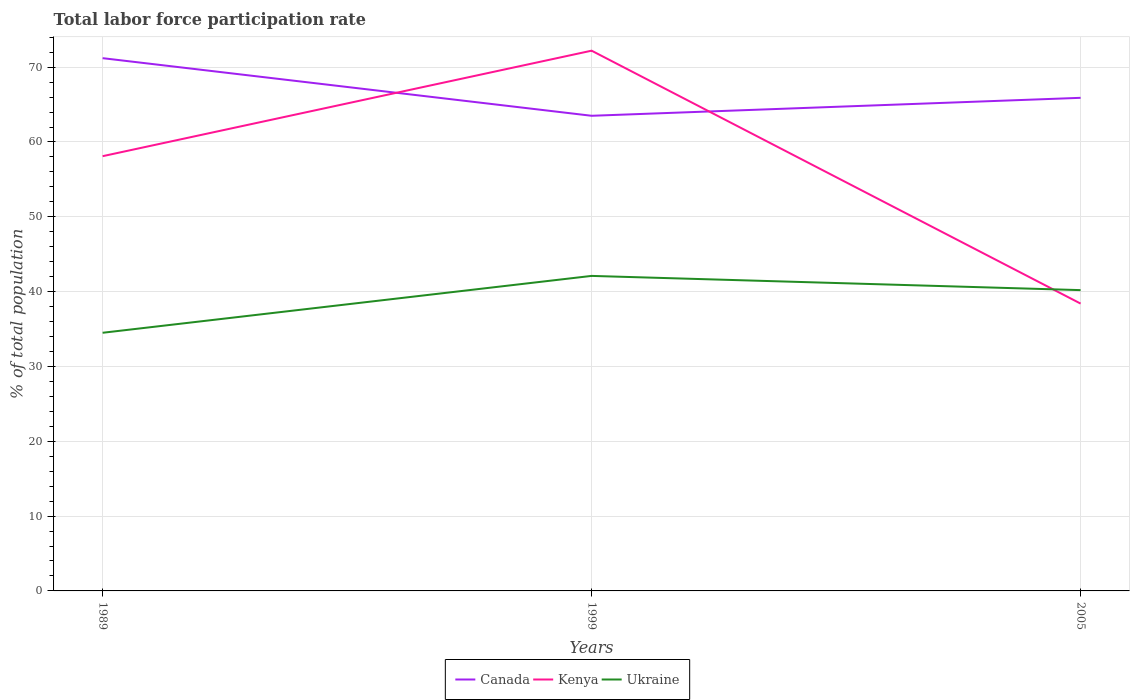How many different coloured lines are there?
Offer a very short reply. 3. Does the line corresponding to Ukraine intersect with the line corresponding to Canada?
Ensure brevity in your answer.  No. Is the number of lines equal to the number of legend labels?
Ensure brevity in your answer.  Yes. Across all years, what is the maximum total labor force participation rate in Kenya?
Offer a terse response. 38.4. What is the total total labor force participation rate in Kenya in the graph?
Provide a succinct answer. 19.7. What is the difference between the highest and the second highest total labor force participation rate in Kenya?
Your answer should be compact. 33.8. Is the total labor force participation rate in Kenya strictly greater than the total labor force participation rate in Canada over the years?
Make the answer very short. No. What is the difference between two consecutive major ticks on the Y-axis?
Ensure brevity in your answer.  10. How many legend labels are there?
Provide a succinct answer. 3. What is the title of the graph?
Provide a short and direct response. Total labor force participation rate. Does "Benin" appear as one of the legend labels in the graph?
Your answer should be compact. No. What is the label or title of the X-axis?
Make the answer very short. Years. What is the label or title of the Y-axis?
Provide a short and direct response. % of total population. What is the % of total population of Canada in 1989?
Provide a short and direct response. 71.2. What is the % of total population of Kenya in 1989?
Your response must be concise. 58.1. What is the % of total population in Ukraine in 1989?
Offer a terse response. 34.5. What is the % of total population of Canada in 1999?
Your answer should be compact. 63.5. What is the % of total population of Kenya in 1999?
Provide a succinct answer. 72.2. What is the % of total population in Ukraine in 1999?
Your answer should be compact. 42.1. What is the % of total population in Canada in 2005?
Your response must be concise. 65.9. What is the % of total population of Kenya in 2005?
Your answer should be very brief. 38.4. What is the % of total population in Ukraine in 2005?
Make the answer very short. 40.2. Across all years, what is the maximum % of total population of Canada?
Offer a terse response. 71.2. Across all years, what is the maximum % of total population in Kenya?
Provide a short and direct response. 72.2. Across all years, what is the maximum % of total population in Ukraine?
Provide a short and direct response. 42.1. Across all years, what is the minimum % of total population in Canada?
Ensure brevity in your answer.  63.5. Across all years, what is the minimum % of total population of Kenya?
Make the answer very short. 38.4. Across all years, what is the minimum % of total population in Ukraine?
Offer a very short reply. 34.5. What is the total % of total population in Canada in the graph?
Provide a short and direct response. 200.6. What is the total % of total population of Kenya in the graph?
Give a very brief answer. 168.7. What is the total % of total population in Ukraine in the graph?
Your response must be concise. 116.8. What is the difference between the % of total population in Kenya in 1989 and that in 1999?
Give a very brief answer. -14.1. What is the difference between the % of total population of Ukraine in 1989 and that in 1999?
Provide a succinct answer. -7.6. What is the difference between the % of total population in Kenya in 1999 and that in 2005?
Offer a terse response. 33.8. What is the difference between the % of total population in Ukraine in 1999 and that in 2005?
Keep it short and to the point. 1.9. What is the difference between the % of total population of Canada in 1989 and the % of total population of Kenya in 1999?
Give a very brief answer. -1. What is the difference between the % of total population in Canada in 1989 and the % of total population in Ukraine in 1999?
Keep it short and to the point. 29.1. What is the difference between the % of total population of Canada in 1989 and the % of total population of Kenya in 2005?
Provide a short and direct response. 32.8. What is the difference between the % of total population in Canada in 1989 and the % of total population in Ukraine in 2005?
Ensure brevity in your answer.  31. What is the difference between the % of total population of Kenya in 1989 and the % of total population of Ukraine in 2005?
Offer a terse response. 17.9. What is the difference between the % of total population of Canada in 1999 and the % of total population of Kenya in 2005?
Your answer should be very brief. 25.1. What is the difference between the % of total population in Canada in 1999 and the % of total population in Ukraine in 2005?
Provide a short and direct response. 23.3. What is the average % of total population of Canada per year?
Ensure brevity in your answer.  66.87. What is the average % of total population in Kenya per year?
Provide a short and direct response. 56.23. What is the average % of total population in Ukraine per year?
Ensure brevity in your answer.  38.93. In the year 1989, what is the difference between the % of total population in Canada and % of total population in Kenya?
Keep it short and to the point. 13.1. In the year 1989, what is the difference between the % of total population in Canada and % of total population in Ukraine?
Offer a terse response. 36.7. In the year 1989, what is the difference between the % of total population of Kenya and % of total population of Ukraine?
Give a very brief answer. 23.6. In the year 1999, what is the difference between the % of total population of Canada and % of total population of Ukraine?
Provide a succinct answer. 21.4. In the year 1999, what is the difference between the % of total population in Kenya and % of total population in Ukraine?
Offer a terse response. 30.1. In the year 2005, what is the difference between the % of total population in Canada and % of total population in Ukraine?
Provide a short and direct response. 25.7. In the year 2005, what is the difference between the % of total population of Kenya and % of total population of Ukraine?
Keep it short and to the point. -1.8. What is the ratio of the % of total population in Canada in 1989 to that in 1999?
Offer a very short reply. 1.12. What is the ratio of the % of total population of Kenya in 1989 to that in 1999?
Give a very brief answer. 0.8. What is the ratio of the % of total population in Ukraine in 1989 to that in 1999?
Provide a short and direct response. 0.82. What is the ratio of the % of total population in Canada in 1989 to that in 2005?
Your response must be concise. 1.08. What is the ratio of the % of total population in Kenya in 1989 to that in 2005?
Your response must be concise. 1.51. What is the ratio of the % of total population in Ukraine in 1989 to that in 2005?
Ensure brevity in your answer.  0.86. What is the ratio of the % of total population in Canada in 1999 to that in 2005?
Ensure brevity in your answer.  0.96. What is the ratio of the % of total population in Kenya in 1999 to that in 2005?
Provide a short and direct response. 1.88. What is the ratio of the % of total population in Ukraine in 1999 to that in 2005?
Offer a very short reply. 1.05. What is the difference between the highest and the second highest % of total population in Canada?
Your answer should be very brief. 5.3. What is the difference between the highest and the second highest % of total population of Kenya?
Provide a short and direct response. 14.1. What is the difference between the highest and the second highest % of total population in Ukraine?
Offer a terse response. 1.9. What is the difference between the highest and the lowest % of total population in Kenya?
Your answer should be very brief. 33.8. 